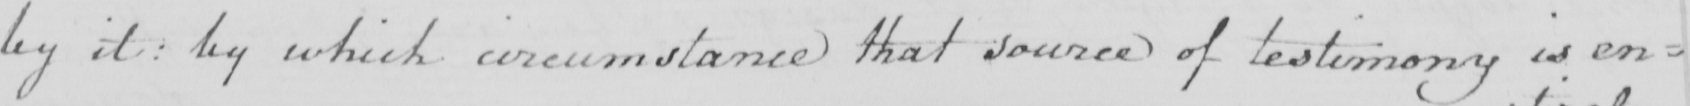Can you tell me what this handwritten text says? by it  :  by which circumstance that source of testimony is en= 